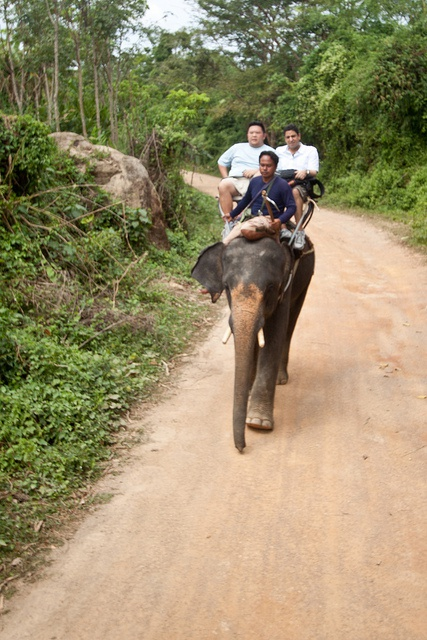Describe the objects in this image and their specific colors. I can see elephant in beige, black, and gray tones, people in beige, black, navy, maroon, and gray tones, people in beige, white, black, and gray tones, people in beige, white, tan, and gray tones, and backpack in beige, black, gray, and maroon tones in this image. 